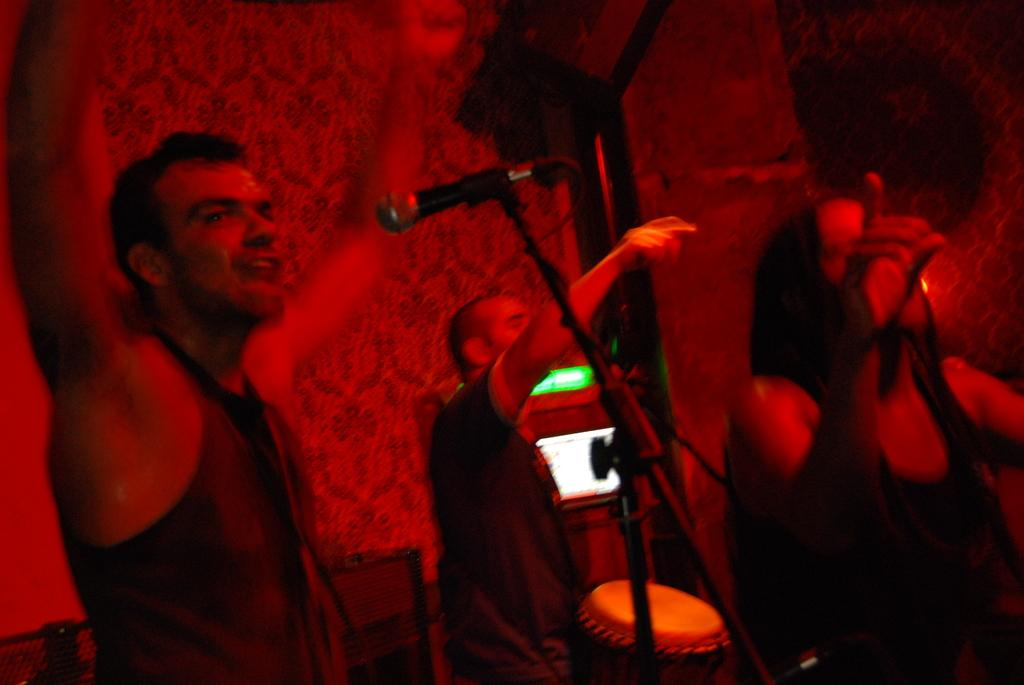Who or what is present in the image? There are people in the image. What object is associated with the people in the image? There is a microphone with a stand in the image. What else can be seen in the image besides the people and the microphone? There is a musical instrument in the image. What can be seen in the background of the image? There is a screen and other objects visible in the background of the image. What direction is the fog moving in the image? There is no fog present in the image. How does the blood flow in the image? There is no blood present in the image. 